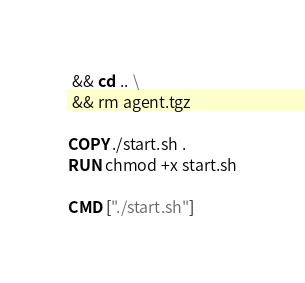<code> <loc_0><loc_0><loc_500><loc_500><_Dockerfile_> && cd .. \
 && rm agent.tgz

COPY ./start.sh .
RUN chmod +x start.sh

CMD ["./start.sh"]
</code> 